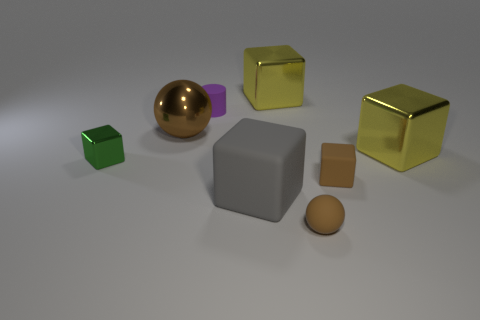There is a purple object; what shape is it? The purple object appears to be a cube, characterized by its equal-length edges and 90-degree angles between faces. 